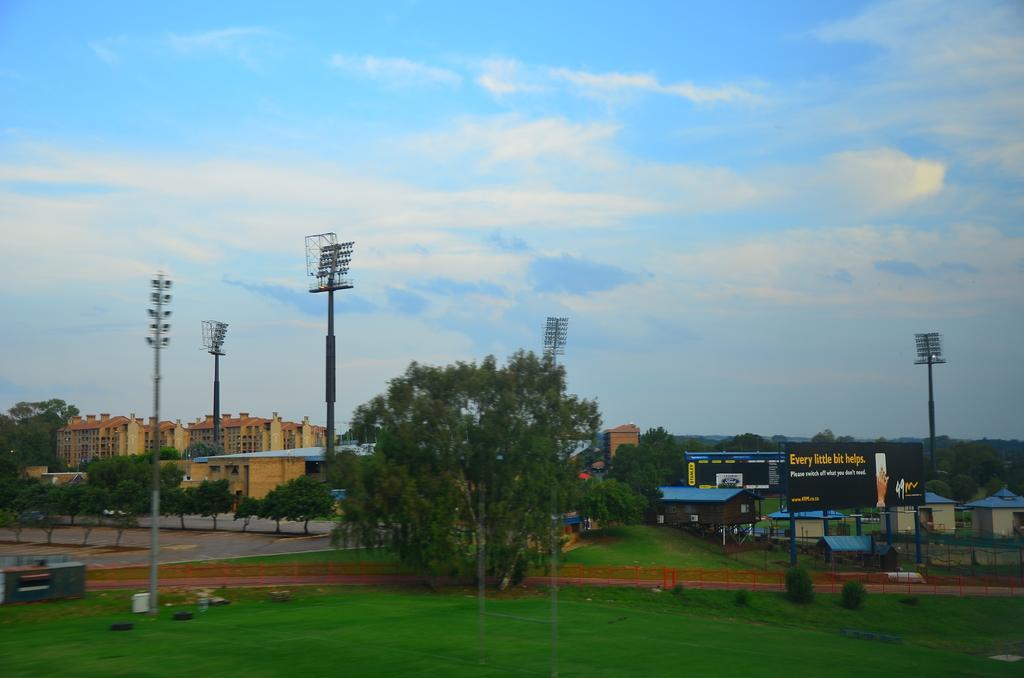Describe this image in one or two sentences. In the foreground of the image we can see some grass, flood lights, houses, board, fencing, tree and in the background of the image there are some buildings, trees and top of the image there is clear sky. 